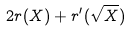<formula> <loc_0><loc_0><loc_500><loc_500>2 r ( X ) + r ^ { \prime } ( \sqrt { X } )</formula> 